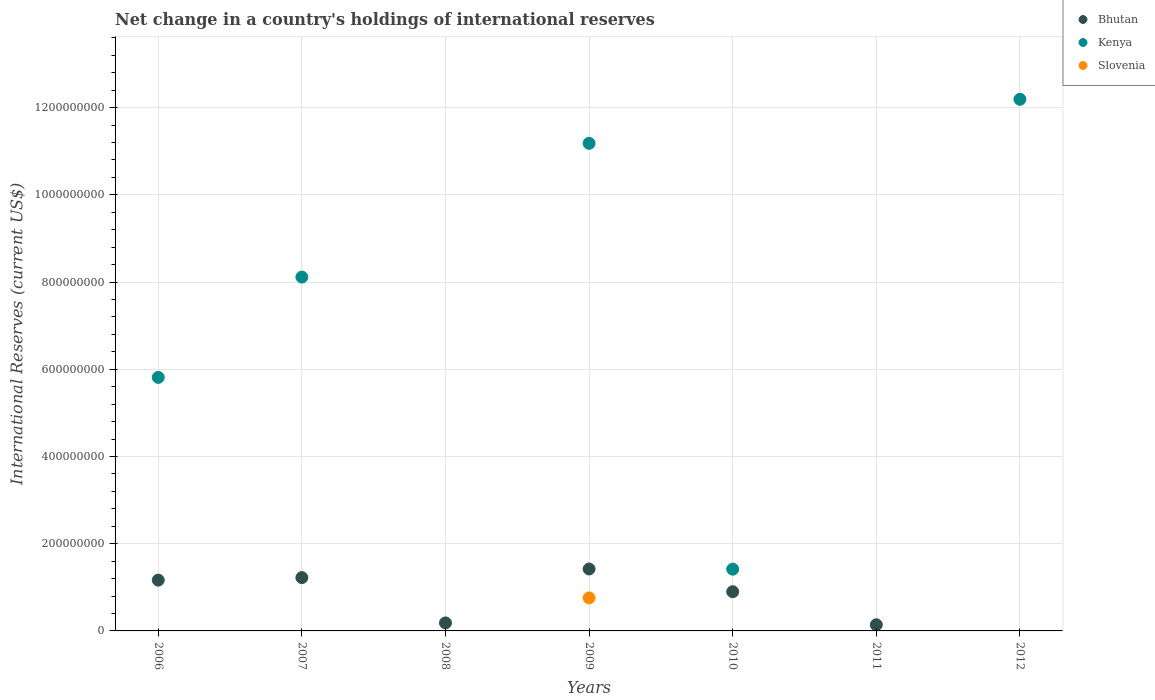How many different coloured dotlines are there?
Provide a succinct answer. 3. What is the international reserves in Bhutan in 2012?
Provide a short and direct response. 0. Across all years, what is the maximum international reserves in Bhutan?
Your response must be concise. 1.42e+08. Across all years, what is the minimum international reserves in Slovenia?
Keep it short and to the point. 0. In which year was the international reserves in Slovenia maximum?
Your answer should be compact. 2009. What is the total international reserves in Kenya in the graph?
Offer a terse response. 3.87e+09. What is the difference between the international reserves in Bhutan in 2009 and that in 2010?
Make the answer very short. 5.21e+07. What is the average international reserves in Bhutan per year?
Your answer should be compact. 7.19e+07. In the year 2006, what is the difference between the international reserves in Bhutan and international reserves in Kenya?
Offer a very short reply. -4.65e+08. What is the ratio of the international reserves in Kenya in 2010 to that in 2012?
Provide a short and direct response. 0.12. Is the international reserves in Bhutan in 2006 less than that in 2008?
Provide a short and direct response. No. Is the difference between the international reserves in Bhutan in 2009 and 2010 greater than the difference between the international reserves in Kenya in 2009 and 2010?
Offer a terse response. No. What is the difference between the highest and the second highest international reserves in Bhutan?
Your response must be concise. 1.97e+07. What is the difference between the highest and the lowest international reserves in Slovenia?
Keep it short and to the point. 7.57e+07. In how many years, is the international reserves in Kenya greater than the average international reserves in Kenya taken over all years?
Offer a terse response. 4. Is the sum of the international reserves in Bhutan in 2008 and 2009 greater than the maximum international reserves in Slovenia across all years?
Offer a very short reply. Yes. Is it the case that in every year, the sum of the international reserves in Bhutan and international reserves in Slovenia  is greater than the international reserves in Kenya?
Your answer should be compact. No. Is the international reserves in Bhutan strictly less than the international reserves in Slovenia over the years?
Give a very brief answer. No. How many years are there in the graph?
Make the answer very short. 7. What is the difference between two consecutive major ticks on the Y-axis?
Your answer should be very brief. 2.00e+08. Are the values on the major ticks of Y-axis written in scientific E-notation?
Your answer should be compact. No. Does the graph contain grids?
Your answer should be very brief. Yes. What is the title of the graph?
Your response must be concise. Net change in a country's holdings of international reserves. Does "Central African Republic" appear as one of the legend labels in the graph?
Your response must be concise. No. What is the label or title of the X-axis?
Keep it short and to the point. Years. What is the label or title of the Y-axis?
Offer a terse response. International Reserves (current US$). What is the International Reserves (current US$) in Bhutan in 2006?
Keep it short and to the point. 1.16e+08. What is the International Reserves (current US$) of Kenya in 2006?
Your answer should be very brief. 5.81e+08. What is the International Reserves (current US$) in Bhutan in 2007?
Offer a terse response. 1.22e+08. What is the International Reserves (current US$) of Kenya in 2007?
Make the answer very short. 8.11e+08. What is the International Reserves (current US$) of Bhutan in 2008?
Ensure brevity in your answer.  1.84e+07. What is the International Reserves (current US$) of Kenya in 2008?
Keep it short and to the point. 0. What is the International Reserves (current US$) in Bhutan in 2009?
Make the answer very short. 1.42e+08. What is the International Reserves (current US$) of Kenya in 2009?
Your response must be concise. 1.12e+09. What is the International Reserves (current US$) in Slovenia in 2009?
Your answer should be compact. 7.57e+07. What is the International Reserves (current US$) of Bhutan in 2010?
Ensure brevity in your answer.  8.99e+07. What is the International Reserves (current US$) of Kenya in 2010?
Provide a short and direct response. 1.42e+08. What is the International Reserves (current US$) in Bhutan in 2011?
Provide a short and direct response. 1.41e+07. What is the International Reserves (current US$) in Kenya in 2011?
Offer a terse response. 0. What is the International Reserves (current US$) in Slovenia in 2011?
Provide a short and direct response. 0. What is the International Reserves (current US$) of Kenya in 2012?
Provide a succinct answer. 1.22e+09. What is the International Reserves (current US$) of Slovenia in 2012?
Your answer should be compact. 0. Across all years, what is the maximum International Reserves (current US$) of Bhutan?
Provide a short and direct response. 1.42e+08. Across all years, what is the maximum International Reserves (current US$) in Kenya?
Your answer should be compact. 1.22e+09. Across all years, what is the maximum International Reserves (current US$) of Slovenia?
Keep it short and to the point. 7.57e+07. Across all years, what is the minimum International Reserves (current US$) of Kenya?
Your response must be concise. 0. Across all years, what is the minimum International Reserves (current US$) of Slovenia?
Keep it short and to the point. 0. What is the total International Reserves (current US$) of Bhutan in the graph?
Keep it short and to the point. 5.03e+08. What is the total International Reserves (current US$) in Kenya in the graph?
Your response must be concise. 3.87e+09. What is the total International Reserves (current US$) in Slovenia in the graph?
Ensure brevity in your answer.  7.57e+07. What is the difference between the International Reserves (current US$) in Bhutan in 2006 and that in 2007?
Offer a terse response. -5.80e+06. What is the difference between the International Reserves (current US$) in Kenya in 2006 and that in 2007?
Give a very brief answer. -2.30e+08. What is the difference between the International Reserves (current US$) in Bhutan in 2006 and that in 2008?
Provide a short and direct response. 9.81e+07. What is the difference between the International Reserves (current US$) of Bhutan in 2006 and that in 2009?
Your answer should be very brief. -2.55e+07. What is the difference between the International Reserves (current US$) of Kenya in 2006 and that in 2009?
Your response must be concise. -5.37e+08. What is the difference between the International Reserves (current US$) in Bhutan in 2006 and that in 2010?
Your response must be concise. 2.66e+07. What is the difference between the International Reserves (current US$) of Kenya in 2006 and that in 2010?
Your answer should be compact. 4.40e+08. What is the difference between the International Reserves (current US$) of Bhutan in 2006 and that in 2011?
Ensure brevity in your answer.  1.02e+08. What is the difference between the International Reserves (current US$) of Kenya in 2006 and that in 2012?
Ensure brevity in your answer.  -6.38e+08. What is the difference between the International Reserves (current US$) in Bhutan in 2007 and that in 2008?
Your response must be concise. 1.04e+08. What is the difference between the International Reserves (current US$) of Bhutan in 2007 and that in 2009?
Your answer should be compact. -1.97e+07. What is the difference between the International Reserves (current US$) of Kenya in 2007 and that in 2009?
Make the answer very short. -3.07e+08. What is the difference between the International Reserves (current US$) of Bhutan in 2007 and that in 2010?
Your answer should be very brief. 3.24e+07. What is the difference between the International Reserves (current US$) in Kenya in 2007 and that in 2010?
Your answer should be very brief. 6.70e+08. What is the difference between the International Reserves (current US$) of Bhutan in 2007 and that in 2011?
Your answer should be very brief. 1.08e+08. What is the difference between the International Reserves (current US$) in Kenya in 2007 and that in 2012?
Provide a short and direct response. -4.08e+08. What is the difference between the International Reserves (current US$) of Bhutan in 2008 and that in 2009?
Provide a succinct answer. -1.24e+08. What is the difference between the International Reserves (current US$) of Bhutan in 2008 and that in 2010?
Your answer should be very brief. -7.15e+07. What is the difference between the International Reserves (current US$) in Bhutan in 2008 and that in 2011?
Make the answer very short. 4.26e+06. What is the difference between the International Reserves (current US$) of Bhutan in 2009 and that in 2010?
Your response must be concise. 5.21e+07. What is the difference between the International Reserves (current US$) in Kenya in 2009 and that in 2010?
Make the answer very short. 9.76e+08. What is the difference between the International Reserves (current US$) in Bhutan in 2009 and that in 2011?
Your response must be concise. 1.28e+08. What is the difference between the International Reserves (current US$) of Kenya in 2009 and that in 2012?
Provide a succinct answer. -1.01e+08. What is the difference between the International Reserves (current US$) of Bhutan in 2010 and that in 2011?
Give a very brief answer. 7.58e+07. What is the difference between the International Reserves (current US$) of Kenya in 2010 and that in 2012?
Keep it short and to the point. -1.08e+09. What is the difference between the International Reserves (current US$) of Bhutan in 2006 and the International Reserves (current US$) of Kenya in 2007?
Make the answer very short. -6.95e+08. What is the difference between the International Reserves (current US$) in Bhutan in 2006 and the International Reserves (current US$) in Kenya in 2009?
Offer a very short reply. -1.00e+09. What is the difference between the International Reserves (current US$) of Bhutan in 2006 and the International Reserves (current US$) of Slovenia in 2009?
Offer a very short reply. 4.07e+07. What is the difference between the International Reserves (current US$) of Kenya in 2006 and the International Reserves (current US$) of Slovenia in 2009?
Make the answer very short. 5.06e+08. What is the difference between the International Reserves (current US$) in Bhutan in 2006 and the International Reserves (current US$) in Kenya in 2010?
Your answer should be compact. -2.51e+07. What is the difference between the International Reserves (current US$) in Bhutan in 2006 and the International Reserves (current US$) in Kenya in 2012?
Your answer should be compact. -1.10e+09. What is the difference between the International Reserves (current US$) in Bhutan in 2007 and the International Reserves (current US$) in Kenya in 2009?
Provide a succinct answer. -9.96e+08. What is the difference between the International Reserves (current US$) in Bhutan in 2007 and the International Reserves (current US$) in Slovenia in 2009?
Keep it short and to the point. 4.65e+07. What is the difference between the International Reserves (current US$) of Kenya in 2007 and the International Reserves (current US$) of Slovenia in 2009?
Ensure brevity in your answer.  7.36e+08. What is the difference between the International Reserves (current US$) in Bhutan in 2007 and the International Reserves (current US$) in Kenya in 2010?
Provide a short and direct response. -1.93e+07. What is the difference between the International Reserves (current US$) in Bhutan in 2007 and the International Reserves (current US$) in Kenya in 2012?
Ensure brevity in your answer.  -1.10e+09. What is the difference between the International Reserves (current US$) of Bhutan in 2008 and the International Reserves (current US$) of Kenya in 2009?
Make the answer very short. -1.10e+09. What is the difference between the International Reserves (current US$) of Bhutan in 2008 and the International Reserves (current US$) of Slovenia in 2009?
Your answer should be compact. -5.74e+07. What is the difference between the International Reserves (current US$) in Bhutan in 2008 and the International Reserves (current US$) in Kenya in 2010?
Provide a short and direct response. -1.23e+08. What is the difference between the International Reserves (current US$) in Bhutan in 2008 and the International Reserves (current US$) in Kenya in 2012?
Offer a terse response. -1.20e+09. What is the difference between the International Reserves (current US$) of Bhutan in 2009 and the International Reserves (current US$) of Kenya in 2010?
Provide a short and direct response. 4.07e+05. What is the difference between the International Reserves (current US$) of Bhutan in 2009 and the International Reserves (current US$) of Kenya in 2012?
Your response must be concise. -1.08e+09. What is the difference between the International Reserves (current US$) of Bhutan in 2010 and the International Reserves (current US$) of Kenya in 2012?
Offer a very short reply. -1.13e+09. What is the difference between the International Reserves (current US$) in Bhutan in 2011 and the International Reserves (current US$) in Kenya in 2012?
Make the answer very short. -1.20e+09. What is the average International Reserves (current US$) in Bhutan per year?
Offer a very short reply. 7.19e+07. What is the average International Reserves (current US$) of Kenya per year?
Offer a very short reply. 5.53e+08. What is the average International Reserves (current US$) in Slovenia per year?
Your answer should be compact. 1.08e+07. In the year 2006, what is the difference between the International Reserves (current US$) of Bhutan and International Reserves (current US$) of Kenya?
Provide a short and direct response. -4.65e+08. In the year 2007, what is the difference between the International Reserves (current US$) in Bhutan and International Reserves (current US$) in Kenya?
Keep it short and to the point. -6.89e+08. In the year 2009, what is the difference between the International Reserves (current US$) in Bhutan and International Reserves (current US$) in Kenya?
Offer a terse response. -9.76e+08. In the year 2009, what is the difference between the International Reserves (current US$) of Bhutan and International Reserves (current US$) of Slovenia?
Give a very brief answer. 6.63e+07. In the year 2009, what is the difference between the International Reserves (current US$) of Kenya and International Reserves (current US$) of Slovenia?
Your answer should be compact. 1.04e+09. In the year 2010, what is the difference between the International Reserves (current US$) of Bhutan and International Reserves (current US$) of Kenya?
Provide a succinct answer. -5.17e+07. What is the ratio of the International Reserves (current US$) of Bhutan in 2006 to that in 2007?
Offer a very short reply. 0.95. What is the ratio of the International Reserves (current US$) of Kenya in 2006 to that in 2007?
Ensure brevity in your answer.  0.72. What is the ratio of the International Reserves (current US$) of Bhutan in 2006 to that in 2008?
Offer a very short reply. 6.34. What is the ratio of the International Reserves (current US$) in Bhutan in 2006 to that in 2009?
Provide a succinct answer. 0.82. What is the ratio of the International Reserves (current US$) of Kenya in 2006 to that in 2009?
Provide a succinct answer. 0.52. What is the ratio of the International Reserves (current US$) of Bhutan in 2006 to that in 2010?
Your answer should be very brief. 1.3. What is the ratio of the International Reserves (current US$) in Kenya in 2006 to that in 2010?
Provide a short and direct response. 4.11. What is the ratio of the International Reserves (current US$) of Bhutan in 2006 to that in 2011?
Keep it short and to the point. 8.25. What is the ratio of the International Reserves (current US$) of Kenya in 2006 to that in 2012?
Your answer should be very brief. 0.48. What is the ratio of the International Reserves (current US$) of Bhutan in 2007 to that in 2008?
Make the answer very short. 6.65. What is the ratio of the International Reserves (current US$) in Bhutan in 2007 to that in 2009?
Keep it short and to the point. 0.86. What is the ratio of the International Reserves (current US$) of Kenya in 2007 to that in 2009?
Provide a short and direct response. 0.73. What is the ratio of the International Reserves (current US$) of Bhutan in 2007 to that in 2010?
Provide a short and direct response. 1.36. What is the ratio of the International Reserves (current US$) of Kenya in 2007 to that in 2010?
Offer a very short reply. 5.73. What is the ratio of the International Reserves (current US$) in Bhutan in 2007 to that in 2011?
Give a very brief answer. 8.66. What is the ratio of the International Reserves (current US$) of Kenya in 2007 to that in 2012?
Offer a very short reply. 0.67. What is the ratio of the International Reserves (current US$) of Bhutan in 2008 to that in 2009?
Keep it short and to the point. 0.13. What is the ratio of the International Reserves (current US$) in Bhutan in 2008 to that in 2010?
Provide a succinct answer. 0.2. What is the ratio of the International Reserves (current US$) in Bhutan in 2008 to that in 2011?
Offer a terse response. 1.3. What is the ratio of the International Reserves (current US$) of Bhutan in 2009 to that in 2010?
Provide a short and direct response. 1.58. What is the ratio of the International Reserves (current US$) in Kenya in 2009 to that in 2010?
Give a very brief answer. 7.9. What is the ratio of the International Reserves (current US$) in Bhutan in 2009 to that in 2011?
Your answer should be very brief. 10.06. What is the ratio of the International Reserves (current US$) of Kenya in 2009 to that in 2012?
Ensure brevity in your answer.  0.92. What is the ratio of the International Reserves (current US$) in Bhutan in 2010 to that in 2011?
Make the answer very short. 6.37. What is the ratio of the International Reserves (current US$) of Kenya in 2010 to that in 2012?
Make the answer very short. 0.12. What is the difference between the highest and the second highest International Reserves (current US$) in Bhutan?
Your answer should be compact. 1.97e+07. What is the difference between the highest and the second highest International Reserves (current US$) in Kenya?
Provide a short and direct response. 1.01e+08. What is the difference between the highest and the lowest International Reserves (current US$) in Bhutan?
Provide a succinct answer. 1.42e+08. What is the difference between the highest and the lowest International Reserves (current US$) in Kenya?
Offer a terse response. 1.22e+09. What is the difference between the highest and the lowest International Reserves (current US$) of Slovenia?
Make the answer very short. 7.57e+07. 